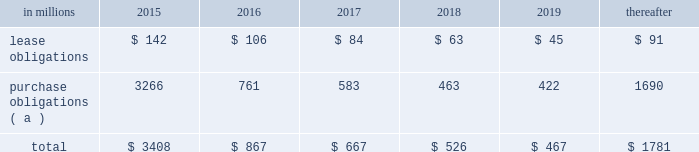At december 31 , 2014 , total future minimum commitments under existing non-cancelable operating leases and purchase obligations were as follows: .
( a ) includes $ 2.3 billion relating to fiber supply agreements entered into at the time of the company 2019s 2006 transformation plan forestland sales and in conjunction with the 2008 acquisition of weyerhaeuser company 2019s containerboard , packaging and recycling business .
Rent expense was $ 154 million , $ 168 million and $ 185 million for 2014 , 2013 and 2012 , respectively .
Guarantees in connection with sales of businesses , property , equipment , forestlands and other assets , international paper commonly makes representations and warranties relating to such businesses or assets , and may agree to indemnify buyers with respect to tax and environmental liabilities , breaches of representations and warranties , and other matters .
Where liabilities for such matters are determined to be probable and subject to reasonable estimation , accrued liabilities are recorded at the time of sale as a cost of the transaction .
Environmental proceedings cercla and state actions international paper has been named as a potentially responsible party in environmental remediation actions under various federal and state laws , including the comprehensive environmental response , compensation and liability act ( cercla ) .
Many of these proceedings involve the cleanup of hazardous substances at large commercial landfills that received waste from many different sources .
While joint and several liability is authorized under cercla and equivalent state laws , as a practical matter , liability for cercla cleanups is typically allocated among the many potential responsible parties .
Remedial costs are recorded in the consolidated financial statements when they become probable and reasonably estimable .
International paper has estimated the probable liability associated with these matters to be approximately $ 95 million in the aggregate as of december 31 , 2014 .
Cass lake : one of the matters referenced above is a closed wood treating facility located in cass lake , minnesota .
During 2009 , in connection with an environmental site remediation action under cercla , international paper submitted to the epa a remediation feasibility study .
In june 2011 , the epa selected and published a proposed soil remedy at the site with an estimated cost of $ 46 million .
The overall remediation reserve for the site is currently $ 50 million to address the selection of an alternative for the soil remediation component of the overall site remedy .
In october 2011 , the epa released a public statement indicating that the final soil remedy decision would be delayed .
In the unlikely event that the epa changes its proposed soil remedy and approves instead a more expensive clean- up alternative , the remediation costs could be material , and significantly higher than amounts currently recorded .
In october 2012 , the natural resource trustees for this site provided notice to international paper and other potentially responsible parties of their intent to perform a natural resource damage assessment .
It is premature to predict the outcome of the assessment or to estimate a loss or range of loss , if any , which may be incurred .
Other remediation costs in addition to the above matters , other remediation costs typically associated with the cleanup of hazardous substances at the company 2019s current , closed or formerly-owned facilities , and recorded as liabilities in the balance sheet , totaled approximately $ 41 million as of december 31 , 2014 .
Other than as described above , completion of required remedial actions is not expected to have a material effect on our consolidated financial statements .
Legal proceedings environmental kalamazoo river : the company is a potentially responsible party with respect to the allied paper , inc./ portage creek/kalamazoo river superfund site ( kalamazoo river superfund site ) in michigan .
The epa asserts that the site is contaminated primarily by pcbs as a result of discharges from various paper mills located along the kalamazoo river , including a paper mill formerly owned by st .
Regis paper company ( st .
Regis ) .
The company is a successor in interest to st .
Regis .
Although the company has not received any orders from the epa , in december 2014 , the epa sent the company a letter demanding payment of $ 19 million to reimburse the epa for costs associated with a time critical removal action of pcb contaminated sediments from a portion of the site .
The company 2019s cercla liability has not been finally determined with respect to this or any other portion of the site and we have declined to reimburse the epa at this time .
As noted below , the company is involved in allocation/ apportionment litigation with regard to the site .
Accordingly , it is premature to estimate a loss or range of loss with respect to this site .
The company was named as a defendant by georgia- pacific consumer products lp , fort james corporation and georgia pacific llc in a contribution and cost recovery action for alleged pollution at the site .
The suit .
In 2015 what percentage of december 31 , 2014 , total future minimum commitments under existing non-cancelable operating leases and purchase obligations is represented by lease obligations? 
Computations: (142 / 3408)
Answer: 0.04167. 